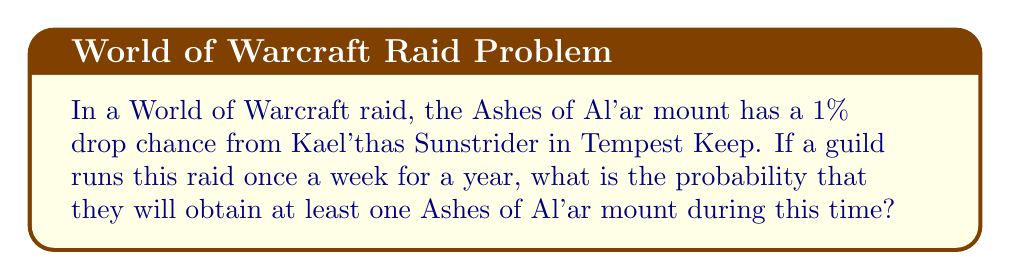Provide a solution to this math problem. Let's approach this step-by-step:

1) First, we need to calculate how many raid attempts the guild will make in a year:
   52 weeks in a year = 52 attempts

2) The probability of not getting the mount on a single attempt is:
   $1 - 0.01 = 0.99$ or 99%

3) To not get the mount for the entire year, this needs to happen 52 times in a row. We can calculate this probability using the multiplication rule:

   $P(\text{no mount in a year}) = 0.99^{52}$

4) We can calculate this:
   $0.99^{52} \approx 0.5880$ or about 58.80%

5) The question asks for the probability of getting at least one mount. This is the opposite of getting no mounts, so we can use the complement rule:

   $P(\text{at least one mount}) = 1 - P(\text{no mount})$

6) Therefore:
   $P(\text{at least one mount}) = 1 - 0.5880 = 0.4120$

So, the probability of obtaining at least one Ashes of Al'ar mount in a year of weekly raids is approximately 0.4120 or 41.20%.
Answer: $1 - 0.99^{52} \approx 0.4120$ or 41.20% 